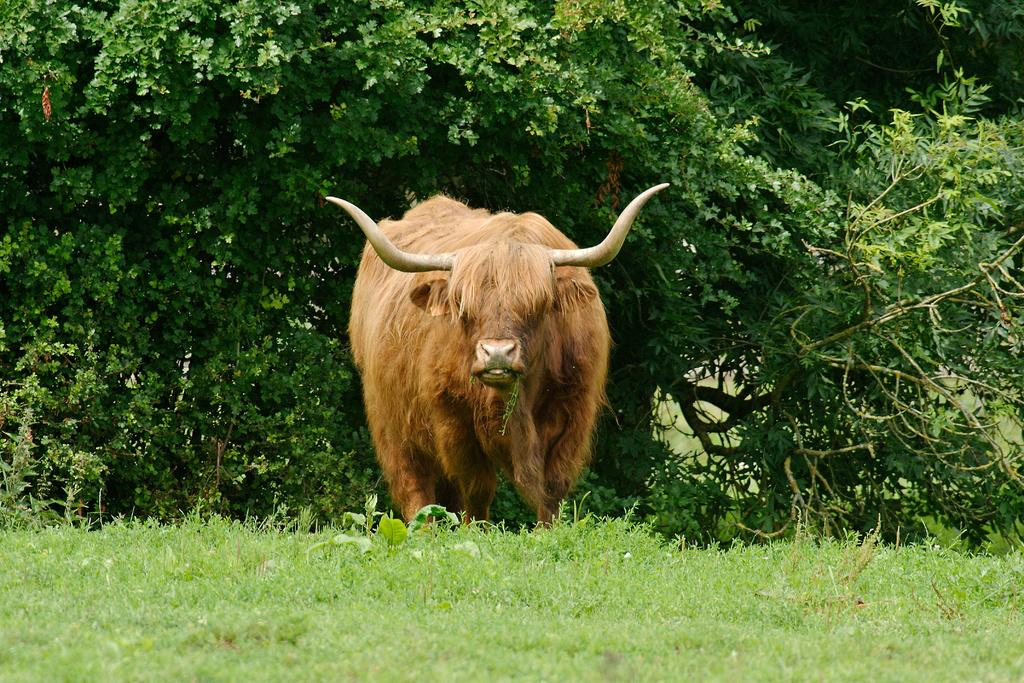What type of animal is in the image? There is a yak in the image. What color is the yak? The yak is brown in color. What type of vegetation is visible at the bottom of the image? There is grass visible at the bottom of the image. What can be seen in the background of the image? There are trees in the background of the image. How many geese are sitting in the basket in the image? There are no geese or baskets present in the image. What type of curtain is hanging near the trees in the image? There is no curtain visible in the image; only the yak, grass, and trees are present. 